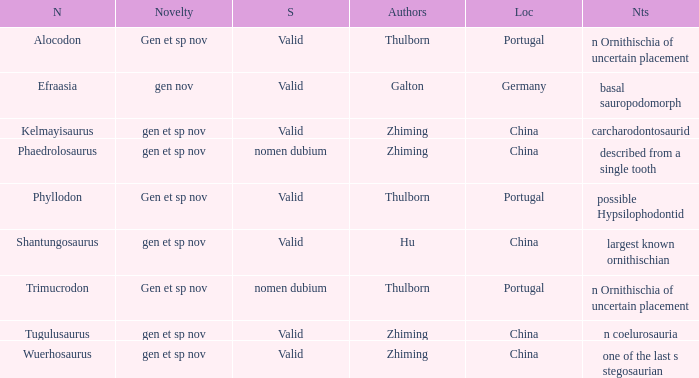What is the Novelty of the dinosaur, whose naming Author was Galton? Gen nov. Can you give me this table as a dict? {'header': ['N', 'Novelty', 'S', 'Authors', 'Loc', 'Nts'], 'rows': [['Alocodon', 'Gen et sp nov', 'Valid', 'Thulborn', 'Portugal', 'n Ornithischia of uncertain placement'], ['Efraasia', 'gen nov', 'Valid', 'Galton', 'Germany', 'basal sauropodomorph'], ['Kelmayisaurus', 'gen et sp nov', 'Valid', 'Zhiming', 'China', 'carcharodontosaurid'], ['Phaedrolosaurus', 'gen et sp nov', 'nomen dubium', 'Zhiming', 'China', 'described from a single tooth'], ['Phyllodon', 'Gen et sp nov', 'Valid', 'Thulborn', 'Portugal', 'possible Hypsilophodontid'], ['Shantungosaurus', 'gen et sp nov', 'Valid', 'Hu', 'China', 'largest known ornithischian'], ['Trimucrodon', 'Gen et sp nov', 'nomen dubium', 'Thulborn', 'Portugal', 'n Ornithischia of uncertain placement'], ['Tugulusaurus', 'gen et sp nov', 'Valid', 'Zhiming', 'China', 'n coelurosauria'], ['Wuerhosaurus', 'gen et sp nov', 'Valid', 'Zhiming', 'China', 'one of the last s stegosaurian']]} 